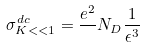Convert formula to latex. <formula><loc_0><loc_0><loc_500><loc_500>\sigma ^ { d c } _ { K < < 1 } = \frac { e ^ { 2 } } { } N _ { D } \frac { 1 } { \epsilon ^ { 3 } }</formula> 